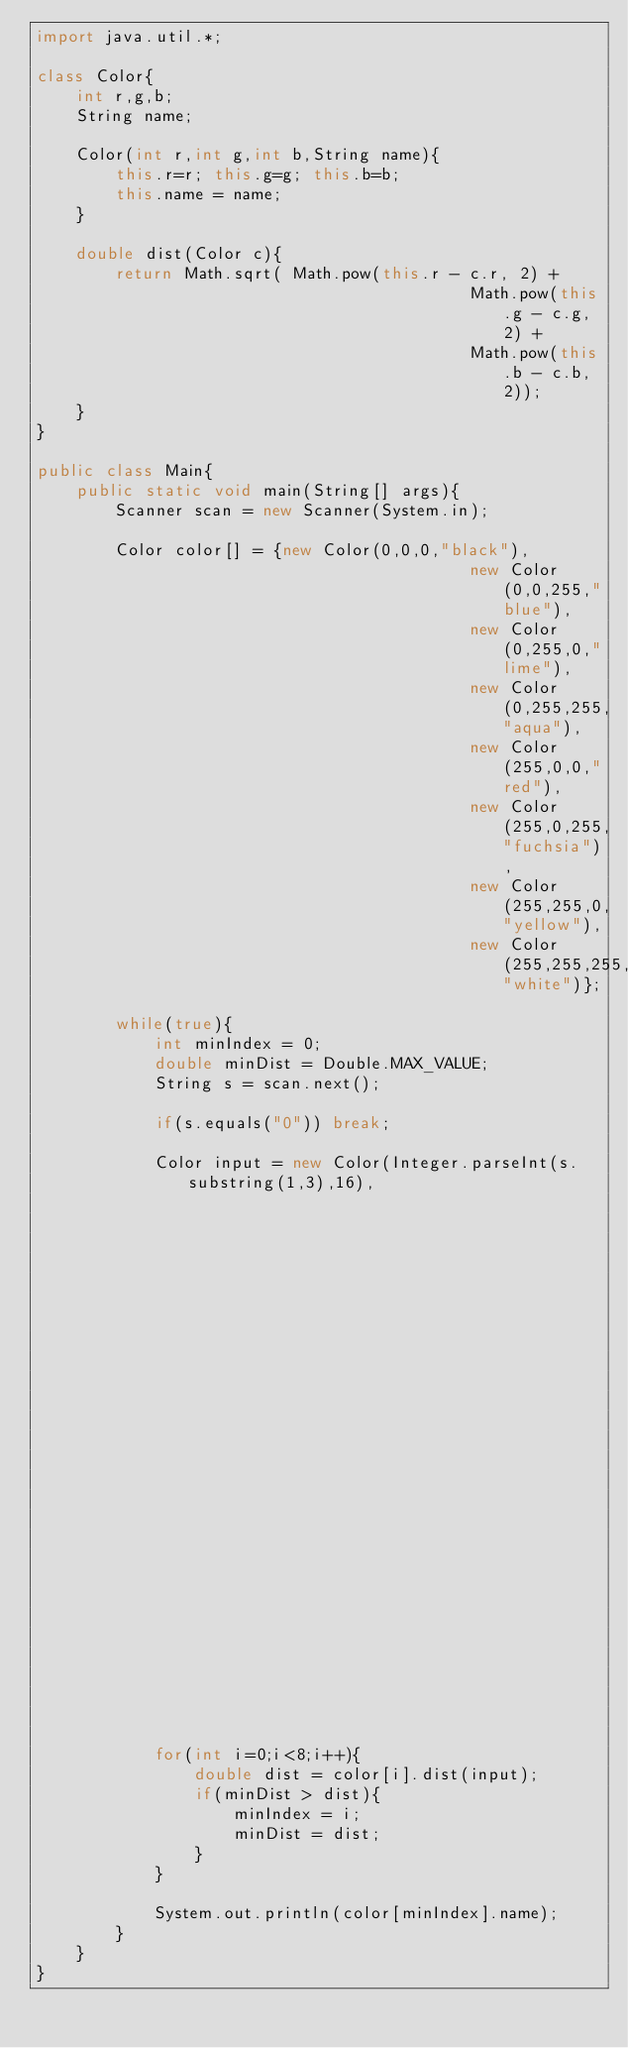<code> <loc_0><loc_0><loc_500><loc_500><_Java_>import java.util.*;

class Color{
	int r,g,b;
	String name;

	Color(int r,int g,int b,String name){
		this.r=r; this.g=g; this.b=b;
		this.name = name;
	}

	double dist(Color c){
		return Math.sqrt( Math.pow(this.r - c.r, 2) +
											Math.pow(this.g - c.g, 2) +
											Math.pow(this.b - c.b, 2));
	}
}

public class Main{
	public static void main(String[] args){
		Scanner scan = new Scanner(System.in);

		Color color[] = {new Color(0,0,0,"black"),
											new Color(0,0,255,"blue"),
											new Color(0,255,0,"lime"),
											new Color(0,255,255,"aqua"),
											new Color(255,0,0,"red"),
											new Color(255,0,255,"fuchsia"),
											new Color(255,255,0,"yellow"),
											new Color(255,255,255,"white")};

		while(true){
			int minIndex = 0;
			double minDist = Double.MAX_VALUE;
			String s = scan.next();

			if(s.equals("0")) break;

			Color input = new Color(Integer.parseInt(s.substring(1,3),16),
															Integer.parseInt(s.substring(3,5),16),
															Integer.parseInt(s.substring(5,7),16),
															"");

			for(int i=0;i<8;i++){
				double dist = color[i].dist(input);
				if(minDist > dist){
					minIndex = i;
					minDist = dist;
				}
			}

			System.out.println(color[minIndex].name);
		}
	}
}</code> 